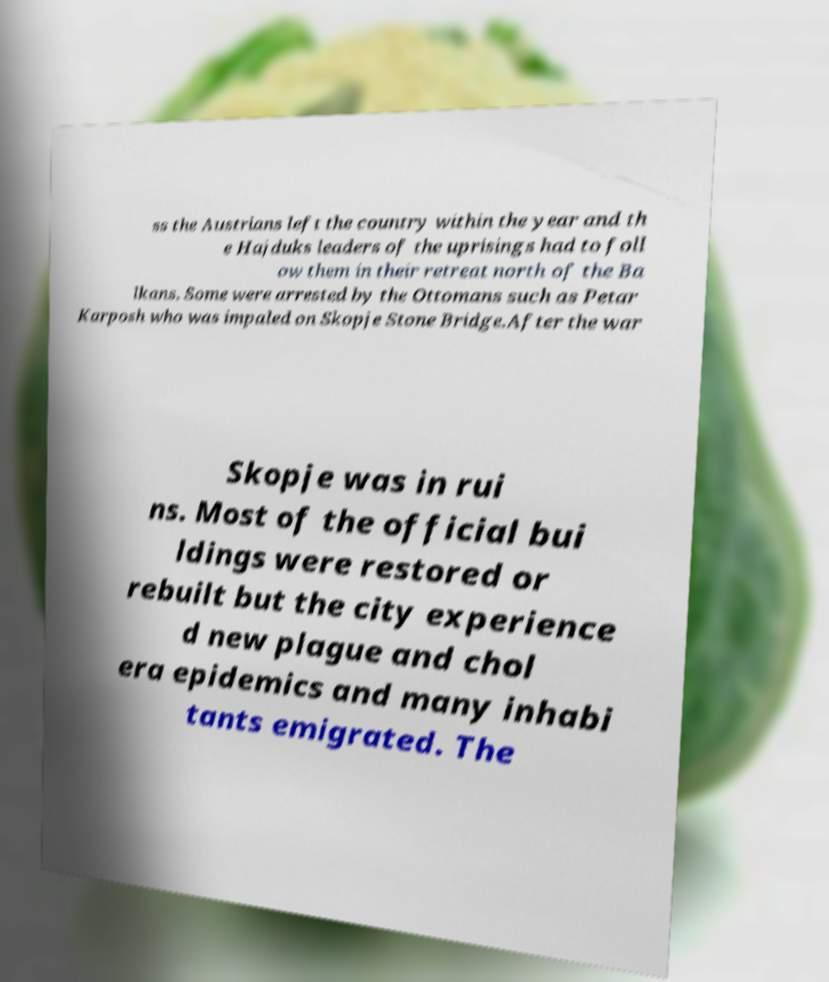For documentation purposes, I need the text within this image transcribed. Could you provide that? ss the Austrians left the country within the year and th e Hajduks leaders of the uprisings had to foll ow them in their retreat north of the Ba lkans. Some were arrested by the Ottomans such as Petar Karposh who was impaled on Skopje Stone Bridge.After the war Skopje was in rui ns. Most of the official bui ldings were restored or rebuilt but the city experience d new plague and chol era epidemics and many inhabi tants emigrated. The 